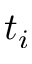<formula> <loc_0><loc_0><loc_500><loc_500>t _ { i }</formula> 